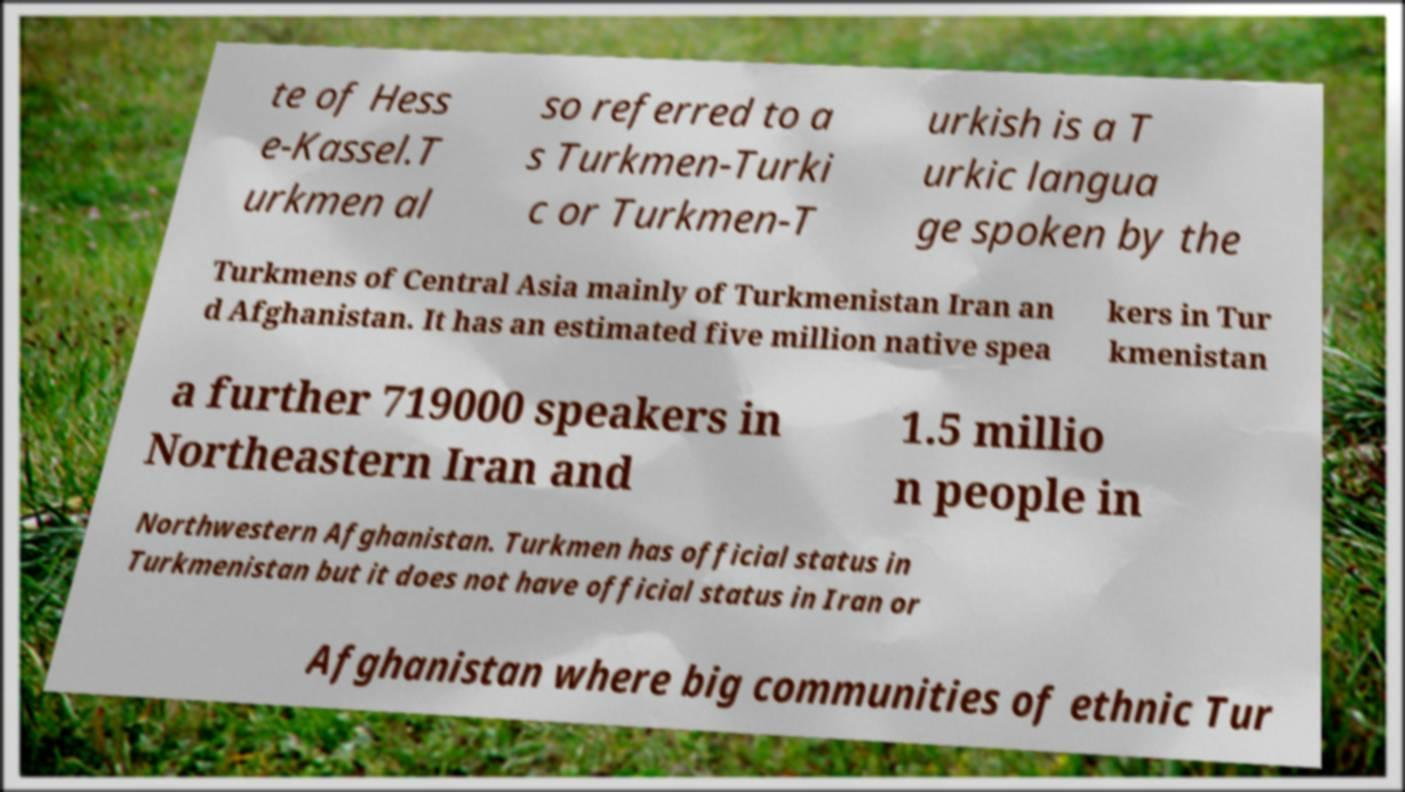Please read and relay the text visible in this image. What does it say? te of Hess e-Kassel.T urkmen al so referred to a s Turkmen-Turki c or Turkmen-T urkish is a T urkic langua ge spoken by the Turkmens of Central Asia mainly of Turkmenistan Iran an d Afghanistan. It has an estimated five million native spea kers in Tur kmenistan a further 719000 speakers in Northeastern Iran and 1.5 millio n people in Northwestern Afghanistan. Turkmen has official status in Turkmenistan but it does not have official status in Iran or Afghanistan where big communities of ethnic Tur 